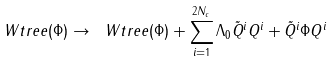<formula> <loc_0><loc_0><loc_500><loc_500>\ W t r e e ( \Phi ) \rightarrow \ W t r e e ( \Phi ) + \sum _ { i = 1 } ^ { 2 N _ { c } } \Lambda _ { 0 } \tilde { Q } ^ { i } Q ^ { i } + \tilde { Q } ^ { i } \Phi Q ^ { i }</formula> 